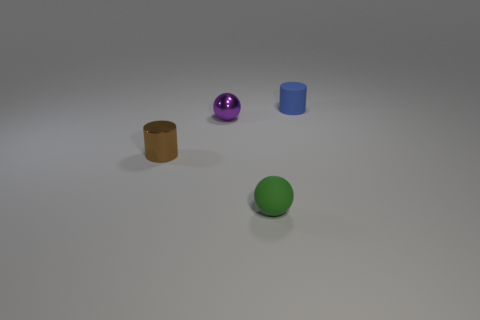Add 2 tiny blue cylinders. How many objects exist? 6 Add 4 tiny green matte balls. How many tiny green matte balls exist? 5 Subtract 0 yellow balls. How many objects are left? 4 Subtract all tiny green rubber balls. Subtract all small green spheres. How many objects are left? 2 Add 3 purple things. How many purple things are left? 4 